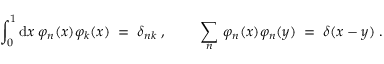Convert formula to latex. <formula><loc_0><loc_0><loc_500><loc_500>\int _ { 0 } ^ { 1 } d x \, \varphi _ { n } ( x ) \varphi _ { k } ( x ) \, = \, \delta _ { n k } \, , \quad \, \sum _ { n } \, \varphi _ { n } ( x ) \varphi _ { n } ( y ) \, = \, \delta ( x - y ) \, .</formula> 